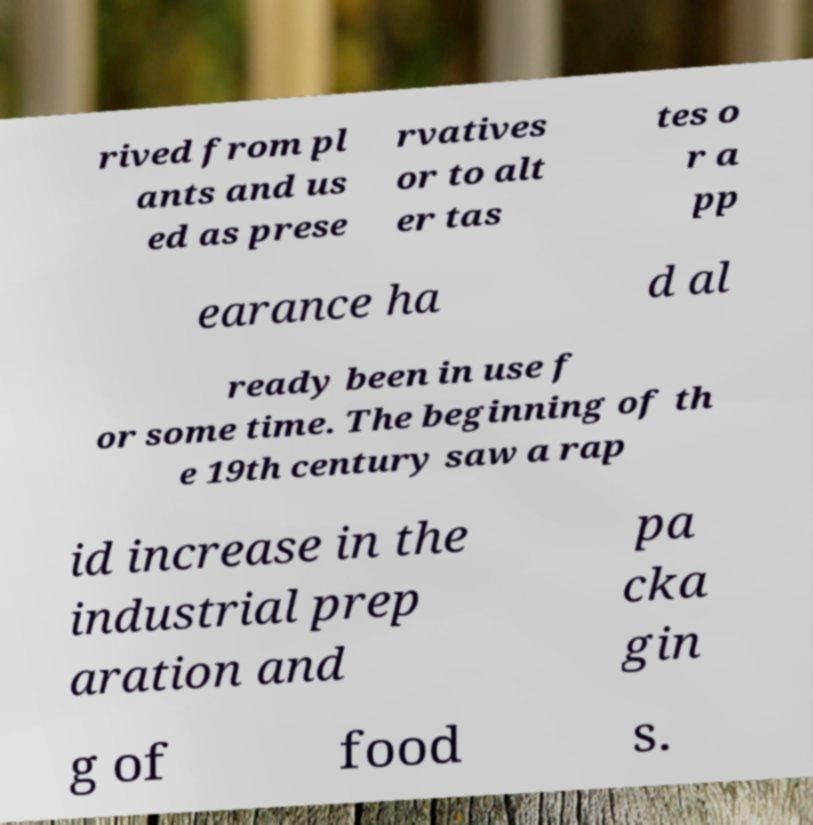There's text embedded in this image that I need extracted. Can you transcribe it verbatim? rived from pl ants and us ed as prese rvatives or to alt er tas tes o r a pp earance ha d al ready been in use f or some time. The beginning of th e 19th century saw a rap id increase in the industrial prep aration and pa cka gin g of food s. 